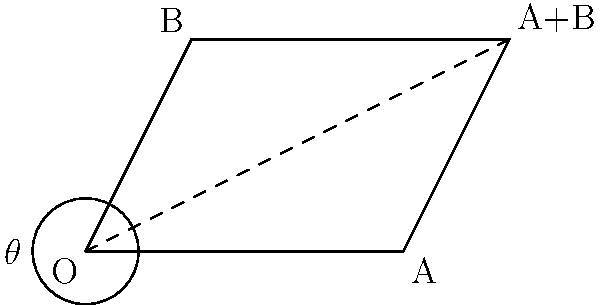During a naval exercise, two vessels depart from the same point O. The first vessel travels 3 nautical miles east, represented by vector $\vec{a}$, while the second vessel travels 2 nautical miles in a direction 60° north of east, represented by vector $\vec{b}$. Calculate the area of the parallelogram formed by these two displacement vectors. To solve this problem, we'll use the cross product of the two vectors, as the magnitude of the cross product equals the area of the parallelogram formed by the vectors.

Step 1: Express the vectors in component form.
$\vec{a} = 3\hat{i} + 0\hat{j}$
$\vec{b} = 2\cos(60°)\hat{i} + 2\sin(60°)\hat{j} = 1\hat{i} + \sqrt{3}\hat{j}$

Step 2: Calculate the cross product $\vec{a} \times \vec{b}$.
$$\vec{a} \times \vec{b} = \begin{vmatrix} 
\hat{i} & \hat{j} & \hat{k} \\
3 & 0 & 0 \\
1 & \sqrt{3} & 0
\end{vmatrix}$$

$$= (3 \cdot \sqrt{3} - 0 \cdot 1)\hat{k} = 3\sqrt{3}\hat{k}$$

Step 3: Find the magnitude of the cross product.
$$|\vec{a} \times \vec{b}| = |3\sqrt{3}| = 3\sqrt{3}$$

The area of the parallelogram is equal to the magnitude of the cross product.

Therefore, the area of the parallelogram is $3\sqrt{3}$ square nautical miles.
Answer: $3\sqrt{3}$ square nautical miles 